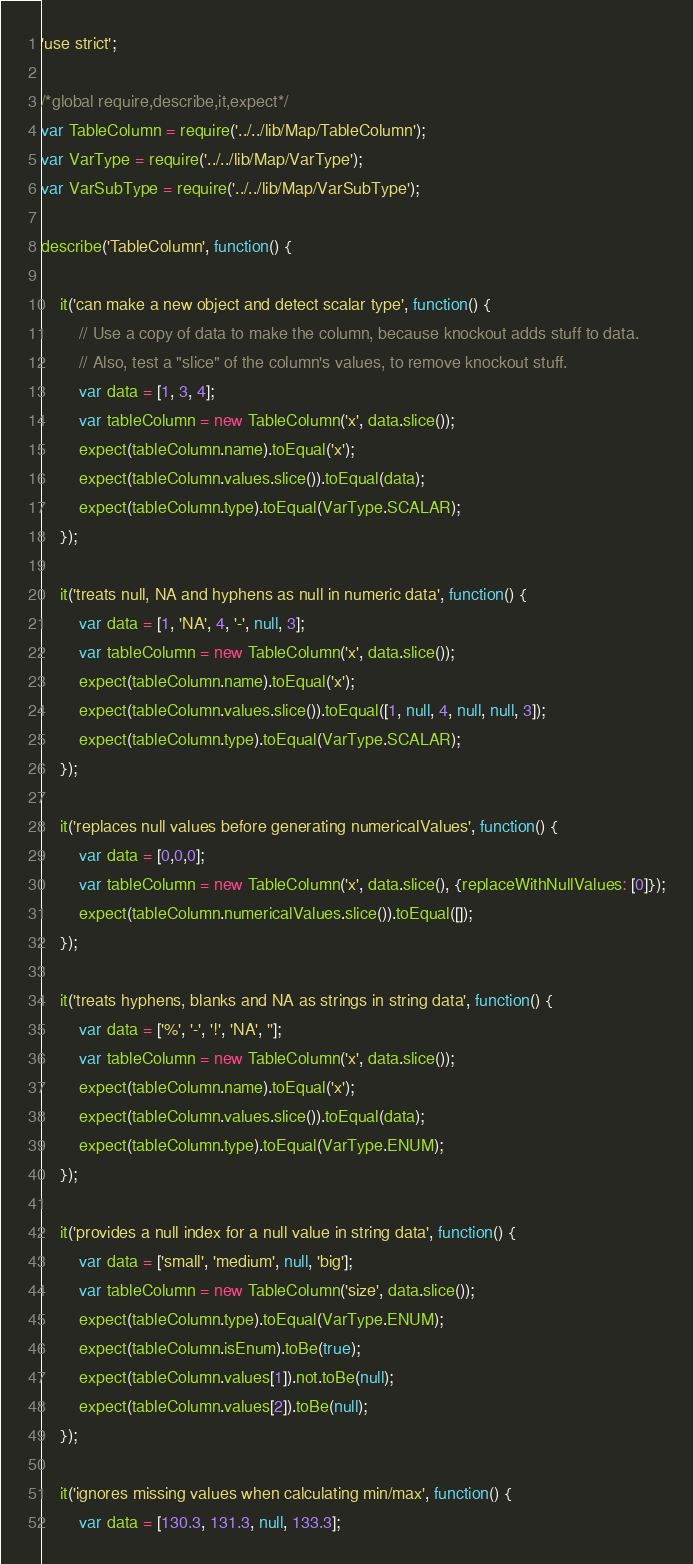<code> <loc_0><loc_0><loc_500><loc_500><_JavaScript_>'use strict';

/*global require,describe,it,expect*/
var TableColumn = require('../../lib/Map/TableColumn');
var VarType = require('../../lib/Map/VarType');
var VarSubType = require('../../lib/Map/VarSubType');

describe('TableColumn', function() {

    it('can make a new object and detect scalar type', function() {
        // Use a copy of data to make the column, because knockout adds stuff to data.
        // Also, test a "slice" of the column's values, to remove knockout stuff.
        var data = [1, 3, 4];
        var tableColumn = new TableColumn('x', data.slice());
        expect(tableColumn.name).toEqual('x');
        expect(tableColumn.values.slice()).toEqual(data);
        expect(tableColumn.type).toEqual(VarType.SCALAR);
    });

    it('treats null, NA and hyphens as null in numeric data', function() {
        var data = [1, 'NA', 4, '-', null, 3];
        var tableColumn = new TableColumn('x', data.slice());
        expect(tableColumn.name).toEqual('x');
        expect(tableColumn.values.slice()).toEqual([1, null, 4, null, null, 3]);
        expect(tableColumn.type).toEqual(VarType.SCALAR);
    });

    it('replaces null values before generating numericalValues', function() {
        var data = [0,0,0];
        var tableColumn = new TableColumn('x', data.slice(), {replaceWithNullValues: [0]});
        expect(tableColumn.numericalValues.slice()).toEqual([]);
    });

    it('treats hyphens, blanks and NA as strings in string data', function() {
        var data = ['%', '-', '!', 'NA', ''];
        var tableColumn = new TableColumn('x', data.slice());
        expect(tableColumn.name).toEqual('x');
        expect(tableColumn.values.slice()).toEqual(data);
        expect(tableColumn.type).toEqual(VarType.ENUM);
    });

    it('provides a null index for a null value in string data', function() {
        var data = ['small', 'medium', null, 'big'];
        var tableColumn = new TableColumn('size', data.slice());
        expect(tableColumn.type).toEqual(VarType.ENUM);
        expect(tableColumn.isEnum).toBe(true);
        expect(tableColumn.values[1]).not.toBe(null);
        expect(tableColumn.values[2]).toBe(null);
    });

    it('ignores missing values when calculating min/max', function() {
        var data = [130.3, 131.3, null, 133.3];</code> 